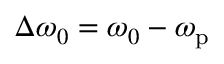Convert formula to latex. <formula><loc_0><loc_0><loc_500><loc_500>\Delta \omega _ { 0 } = \omega _ { 0 } - \omega _ { p }</formula> 